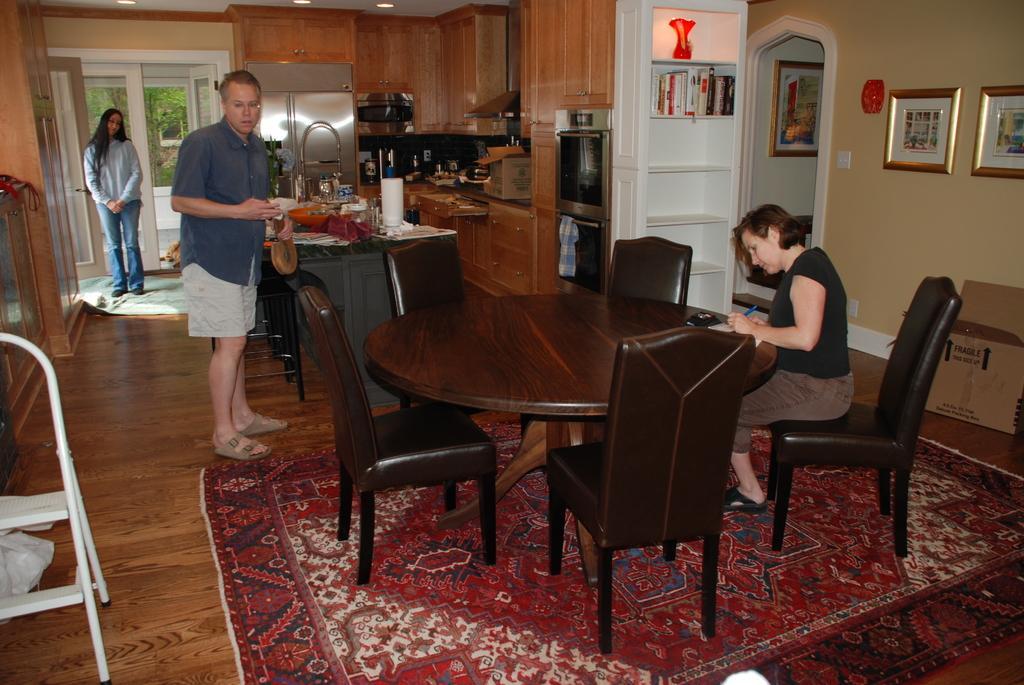Describe this image in one or two sentences. In this image I can see two persons standing, the person in front is sitting on the chair and the person is wearing black and brown color dress, background I can see few frames attached to the wall and the wall is in cream color and I can also see few glasses, bowls on the table. Background I can see few books in the rack and cupboards are in brown color and I can also see few windows and trees in green color. 